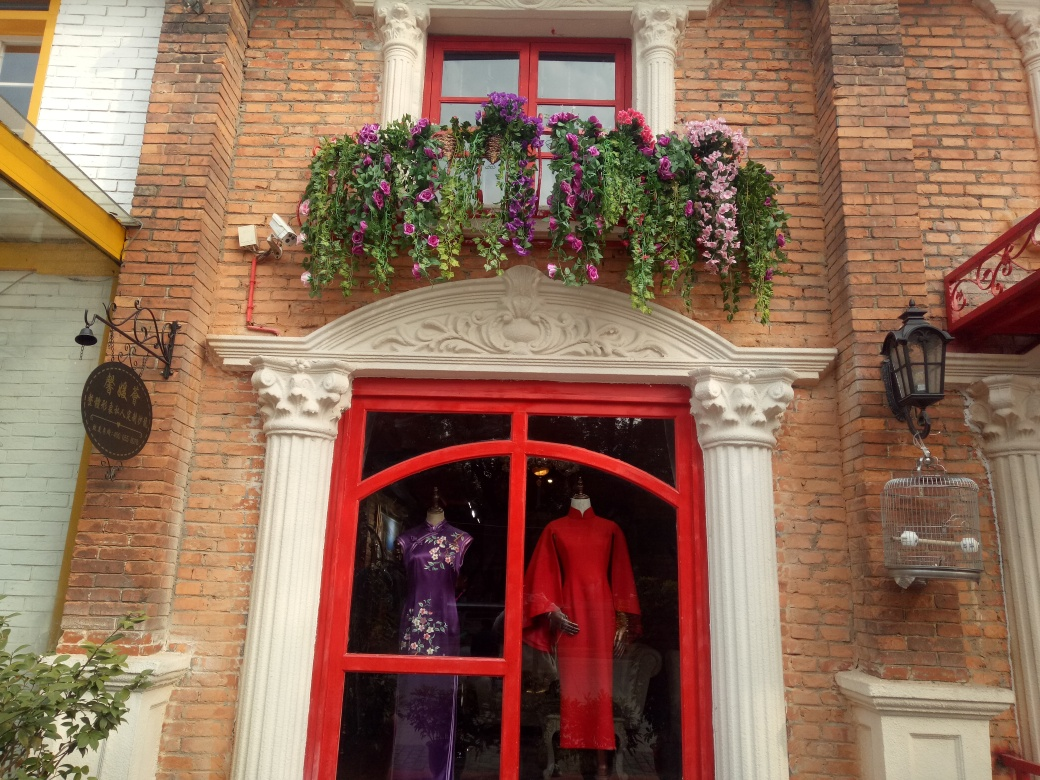What mood does the image evoke? The image evokes a mood of quaintness and charm, likely attributed to the historical look of the brickwork and the presence of the vibrant, blooming flowers. The shop's eye-catching window display adds a touch of elegance and suggests a warm, inviting atmosphere. What time of day or season does it seem to be? Given the natural light and the shadows present, it appears to be daylight, possibly late morning or early afternoon. The presence of lush, vibrant flowers suggests it might be spring or summer when these plants are typically in bloom. 